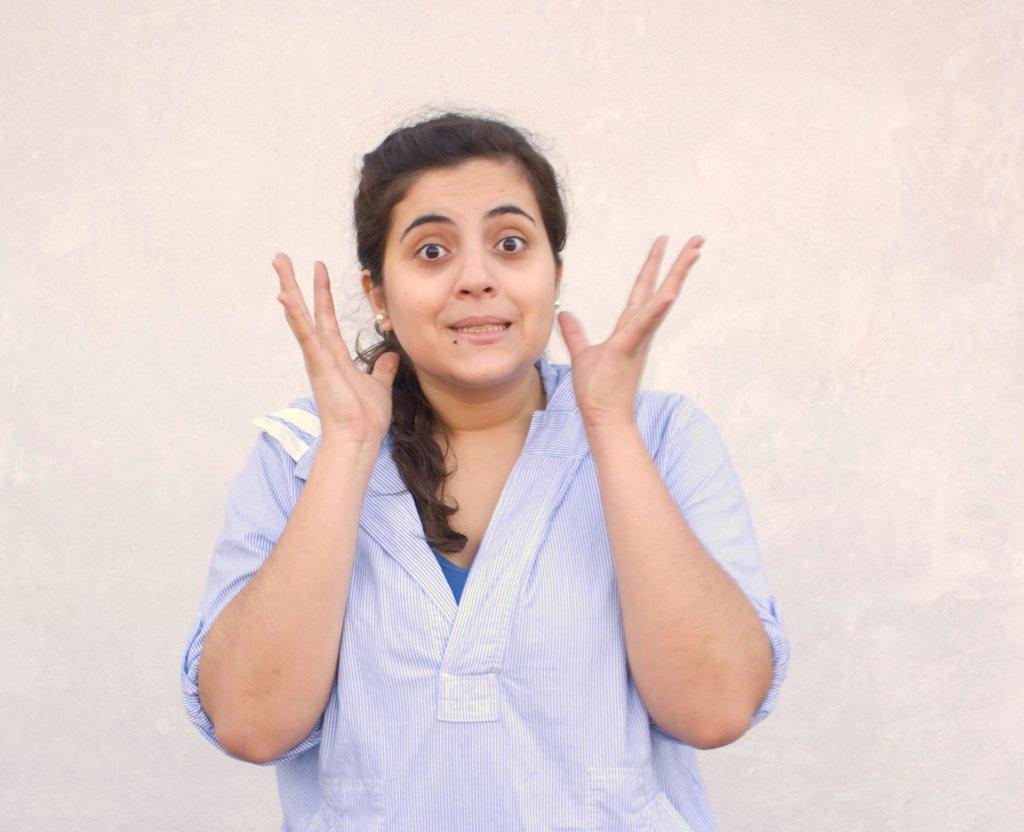Who is the main subject in the image? There is a woman in the image. What is the woman wearing? The woman is wearing a blue dress. What is the color of the background in the image? The background in the image is white. How many earrings is the woman wearing? The woman is wearing earrings in both ears. What type of paint is being used by the woman in the image? There is no paint or painting activity depicted in the image. 